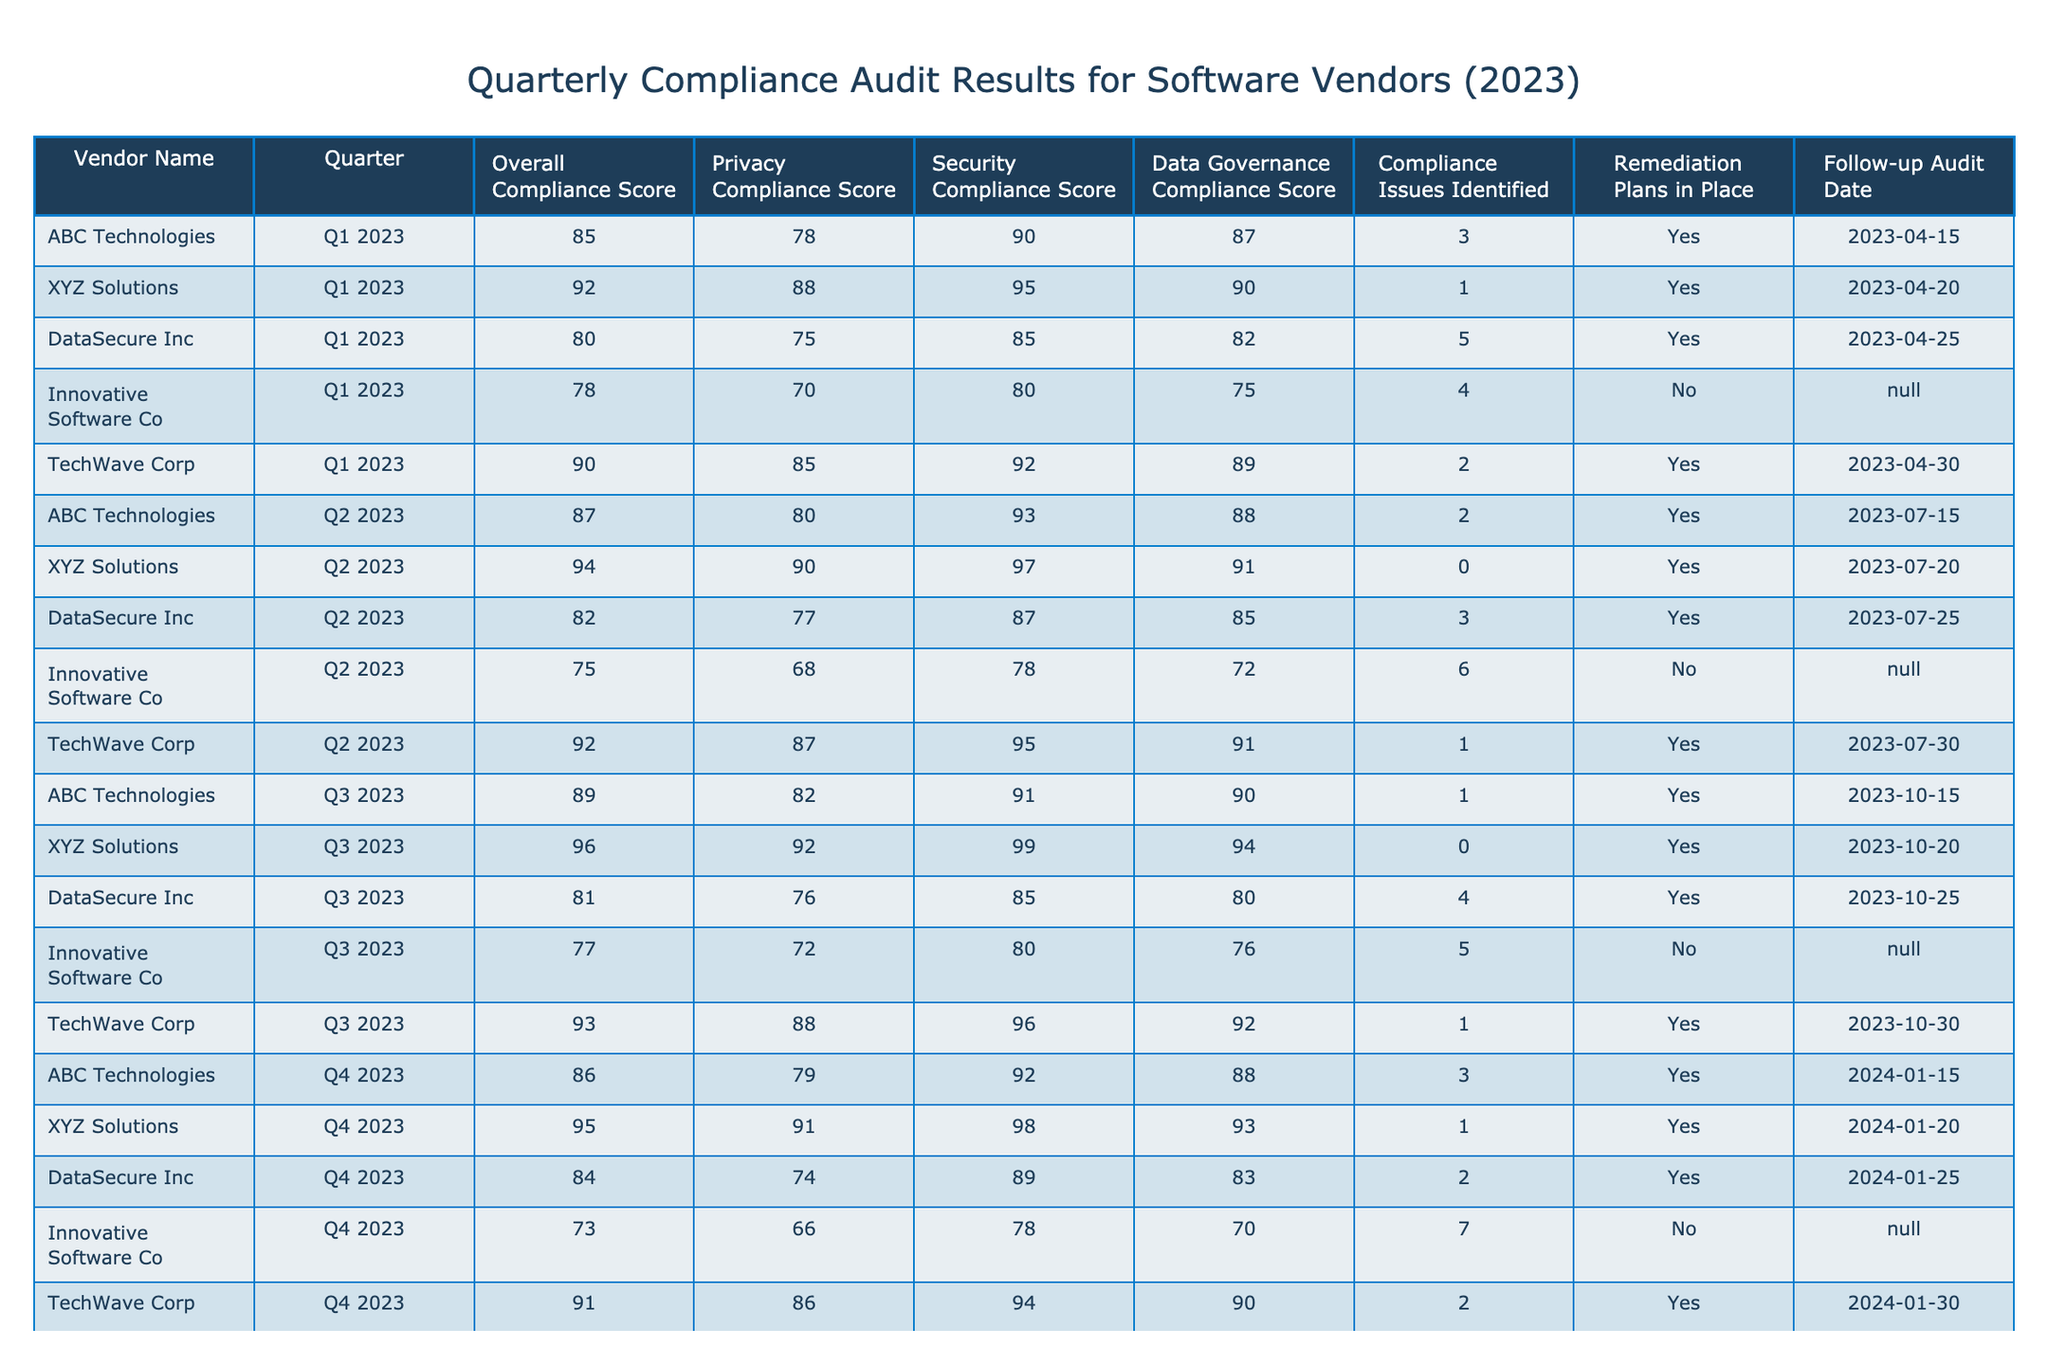What is the overall compliance score of XYZ Solutions in Q3 2023? The table shows that XYZ Solutions has an overall compliance score of 96 in Q3 2023.
Answer: 96 How many compliance issues were identified for DataSecure Inc in Q2 2023? According to the table, DataSecure Inc had 3 compliance issues identified in Q2 2023.
Answer: 3 Which vendor had the highest privacy compliance score in Q1 2023? By examining the privacy compliance scores, XYZ Solutions had the highest score of 88 in Q1 2023.
Answer: XYZ Solutions Did Innovative Software Co have a remediation plan in place for all quarters? The table indicates that Innovative Software Co did not have a remediation plan in place for Q1 2023 and Q2 2023.
Answer: No What is the average overall compliance score for TechWave Corp throughout 2023? TechWave Corp's overall compliance scores are 90, 92, 93, and 91 for the four quarters. Summing these gives 366, and dividing by 4 gives an average score of 91.5.
Answer: 91.5 Determine if XYZ Solutions had any compliance issues identified in Q2 2023. The table shows that XYZ Solutions had 0 compliance issues identified in Q2 2023.
Answer: Yes What is the difference in overall compliance scores between ABC Technologies Q1 and Q2 in 2023? ABC Technologies had an overall compliance score of 85 in Q1 2023 and 87 in Q2 2023. The difference is 87 - 85 = 2.
Answer: 2 Which vendor had the most compliance issues identified across all quarters? By reviewing the compliance issues identified for each vendor across all quarters, Innovative Software Co had a total of 22 issues (4+6+5+7).
Answer: Innovative Software Co What was the follow-up audit date for DataSecure Inc in Q3 2023? The table states that the follow-up audit date for DataSecure Inc in Q3 2023 is 2023-10-25.
Answer: 2023-10-25 List the quarters where TechWave Corp had compliance issues identified. TechWave Corp had 2 compliance issues identified in Q1 and 1 in Q2. Thus, the tickets indicate compliance issues in Q1 and Q2, but not in Q3 or Q4.
Answer: Q1, Q2 